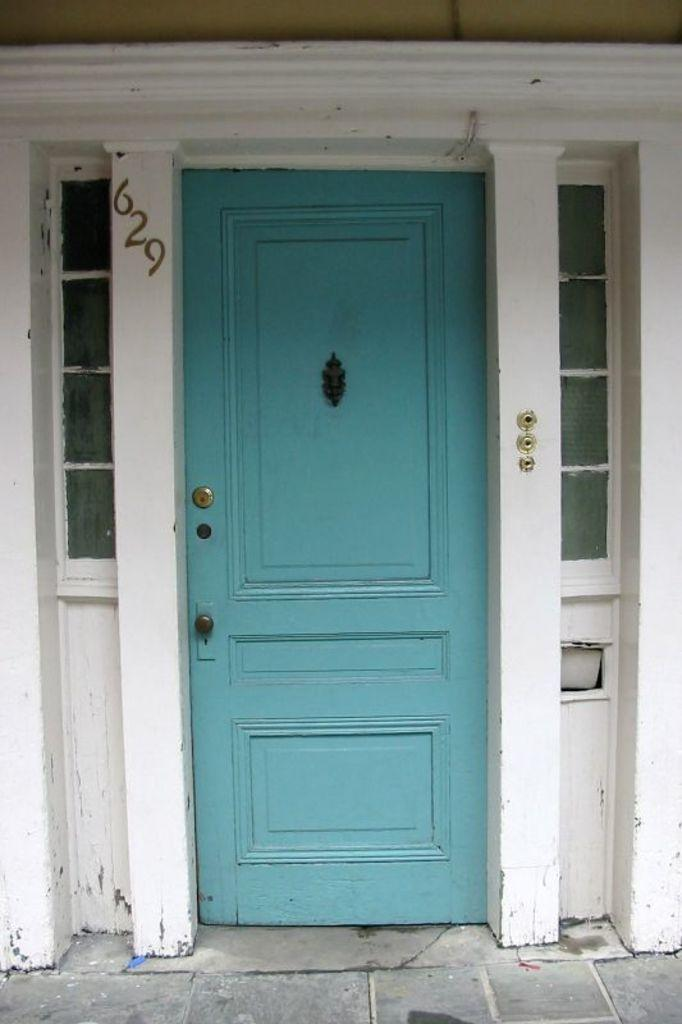What is the main subject in the center of the image? There is a door in the center of the image. What can be seen behind the door in the image? There is a wall in the background of the image. What type of treatment is being administered to the fairies in the image? There are no fairies present in the image, so no treatment is being administered. What is the color of the clam shell in the image? There is no clam shell present in the image. 